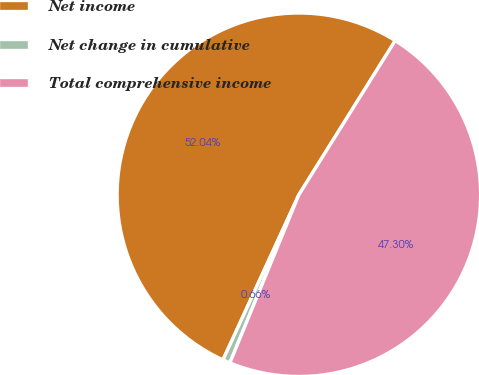Convert chart to OTSL. <chart><loc_0><loc_0><loc_500><loc_500><pie_chart><fcel>Net income<fcel>Net change in cumulative<fcel>Total comprehensive income<nl><fcel>52.03%<fcel>0.66%<fcel>47.3%<nl></chart> 